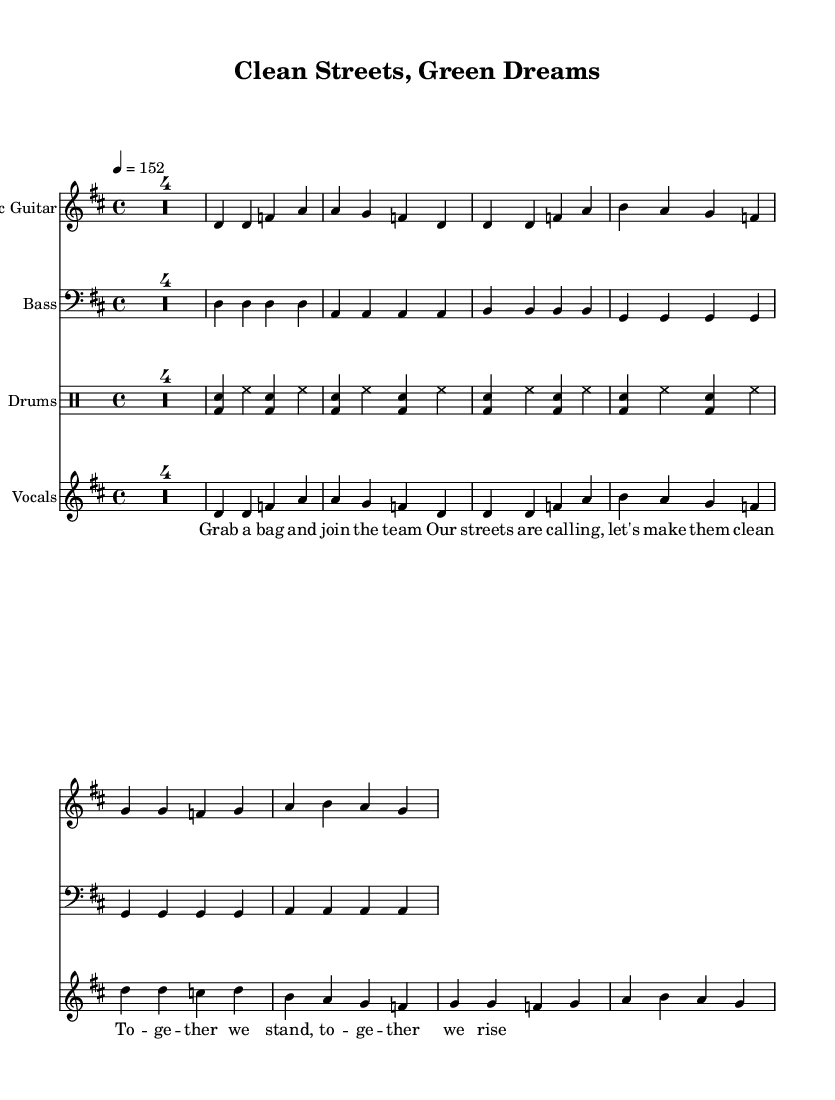What is the key signature of this music? The key signature is indicated at the beginning of the music and shows that the piece is in D major, which has two sharps: F# and C#.
Answer: D major What is the time signature of this music? The time signature is located at the start of the music, showing a 4/4 time signature, meaning there are four beats in a measure, and the quarter note gets one beat.
Answer: 4/4 What is the tempo marking for this piece? The tempo marking is found within the global section and indicates a beat of 152 beats per minute, indicating how fast the music should be played.
Answer: 152 How many measures are in the chorus section? The chorus consists of two measures, which can be counted by looking at the notation for the chorus section within the music.
Answer: 2 What instruments are featured in this piece? The instruments are specified at the beginning of each staff; they include electric guitar, bass, drums, and vocals.
Answer: Electric guitar, bass, drums, vocals What is the main theme of the song based on the lyrics? The lyrics mentioned refer to actively participating in community clean-up efforts, focusing on words like "join," "clean," and "together," emphasizing collective action.
Answer: Community clean-up 